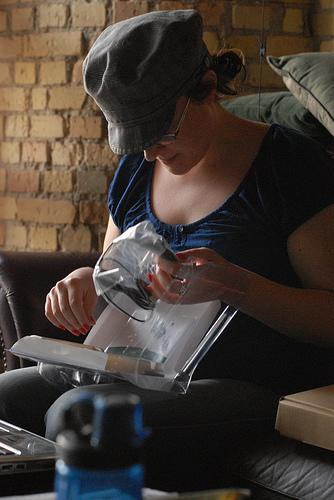Question: where is this scene?
Choices:
A. My house.
B. At a cafe.
C. Your house.
D. My other friends house.
Answer with the letter. Answer: B Question: what is she holding?
Choices:
A. Cable.
B. String.
C. Wire.
D. Tie.
Answer with the letter. Answer: C Question: who is this?
Choices:
A. Woman.
B. Queen.
C. Lady.
D. Princess.
Answer with the letter. Answer: C Question: what color is her top?
Choices:
A. Black.
B. Blue.
C. Pink.
D. Purple.
Answer with the letter. Answer: B 